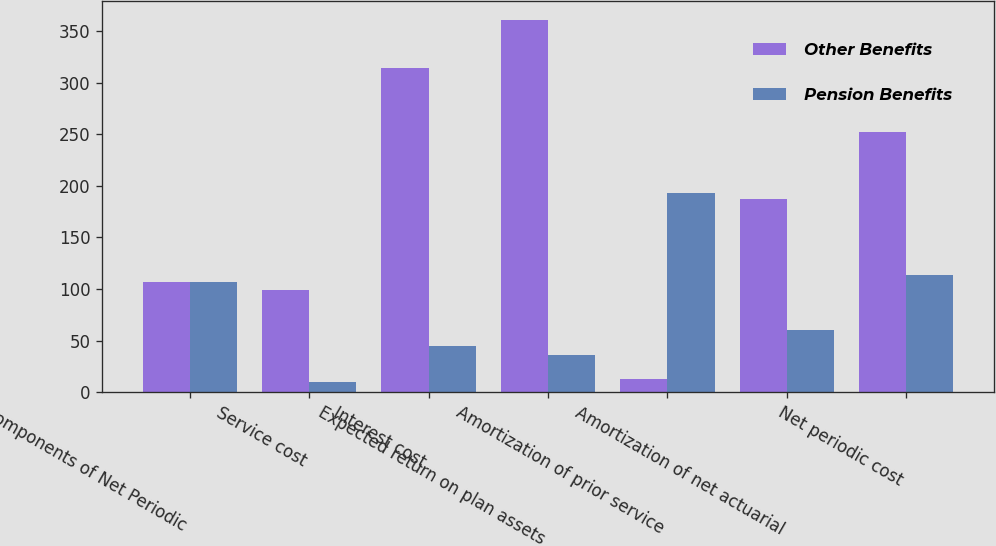Convert chart. <chart><loc_0><loc_0><loc_500><loc_500><stacked_bar_chart><ecel><fcel>Components of Net Periodic<fcel>Service cost<fcel>Interest cost<fcel>Expected return on plan assets<fcel>Amortization of prior service<fcel>Amortization of net actuarial<fcel>Net periodic cost<nl><fcel>Other Benefits<fcel>106.5<fcel>99<fcel>314<fcel>361<fcel>13<fcel>187<fcel>252<nl><fcel>Pension Benefits<fcel>106.5<fcel>10<fcel>45<fcel>36<fcel>193<fcel>60<fcel>114<nl></chart> 